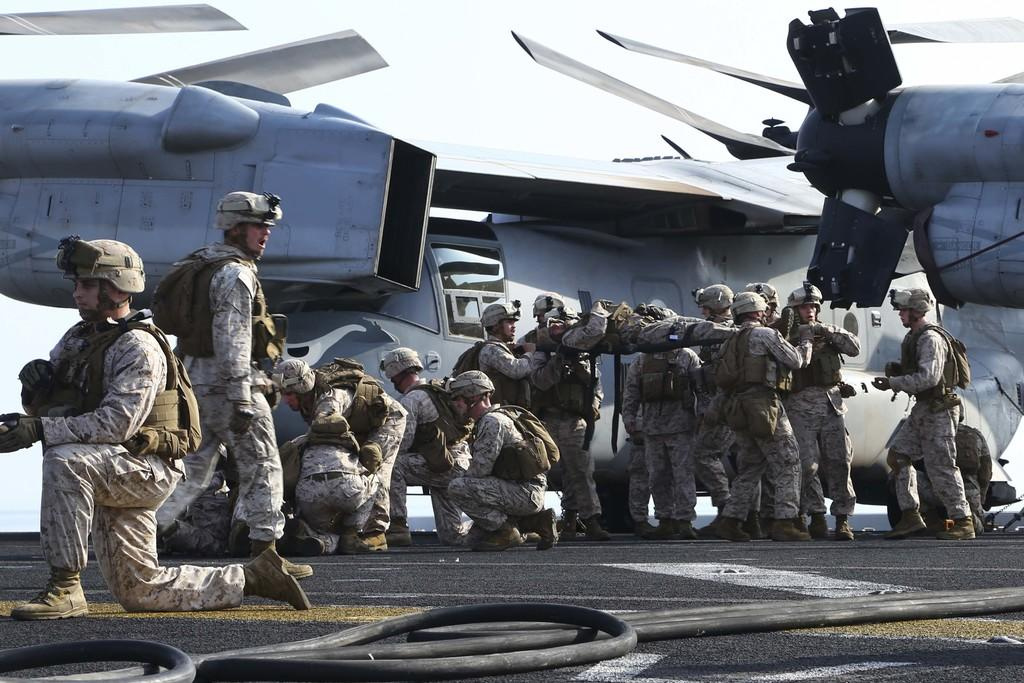What is the main subject of the image? The main subject of the image is aircrafts. What are the people in the image wearing? The people in the image are wearing uniforms. What object can be seen on the road in the image? There is a pipe placed on the road in the image. What can be seen in the background of the image? The sky is visible in the background of the image. How many tomatoes are being carried by the people in the image? There are no tomatoes present in the image; the people are wearing uniforms and there is no indication of them carrying tomatoes. 